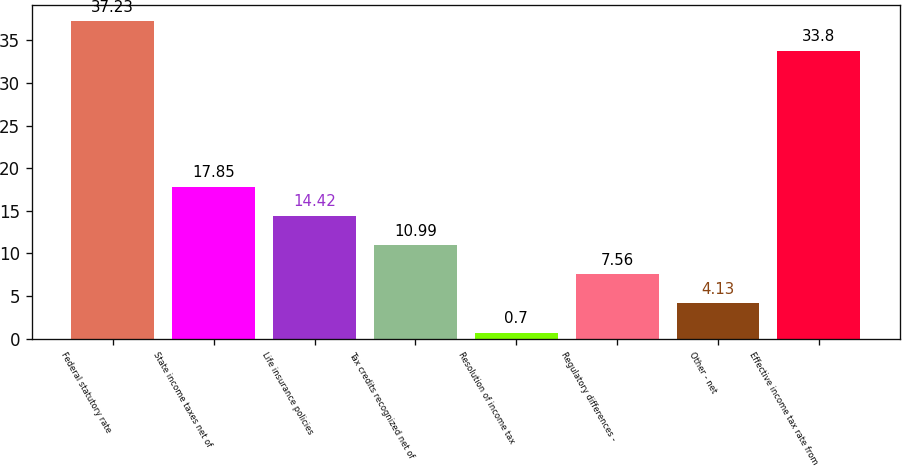Convert chart to OTSL. <chart><loc_0><loc_0><loc_500><loc_500><bar_chart><fcel>Federal statutory rate<fcel>State income taxes net of<fcel>Life insurance policies<fcel>Tax credits recognized net of<fcel>Resolution of income tax<fcel>Regulatory differences -<fcel>Other - net<fcel>Effective income tax rate from<nl><fcel>37.23<fcel>17.85<fcel>14.42<fcel>10.99<fcel>0.7<fcel>7.56<fcel>4.13<fcel>33.8<nl></chart> 